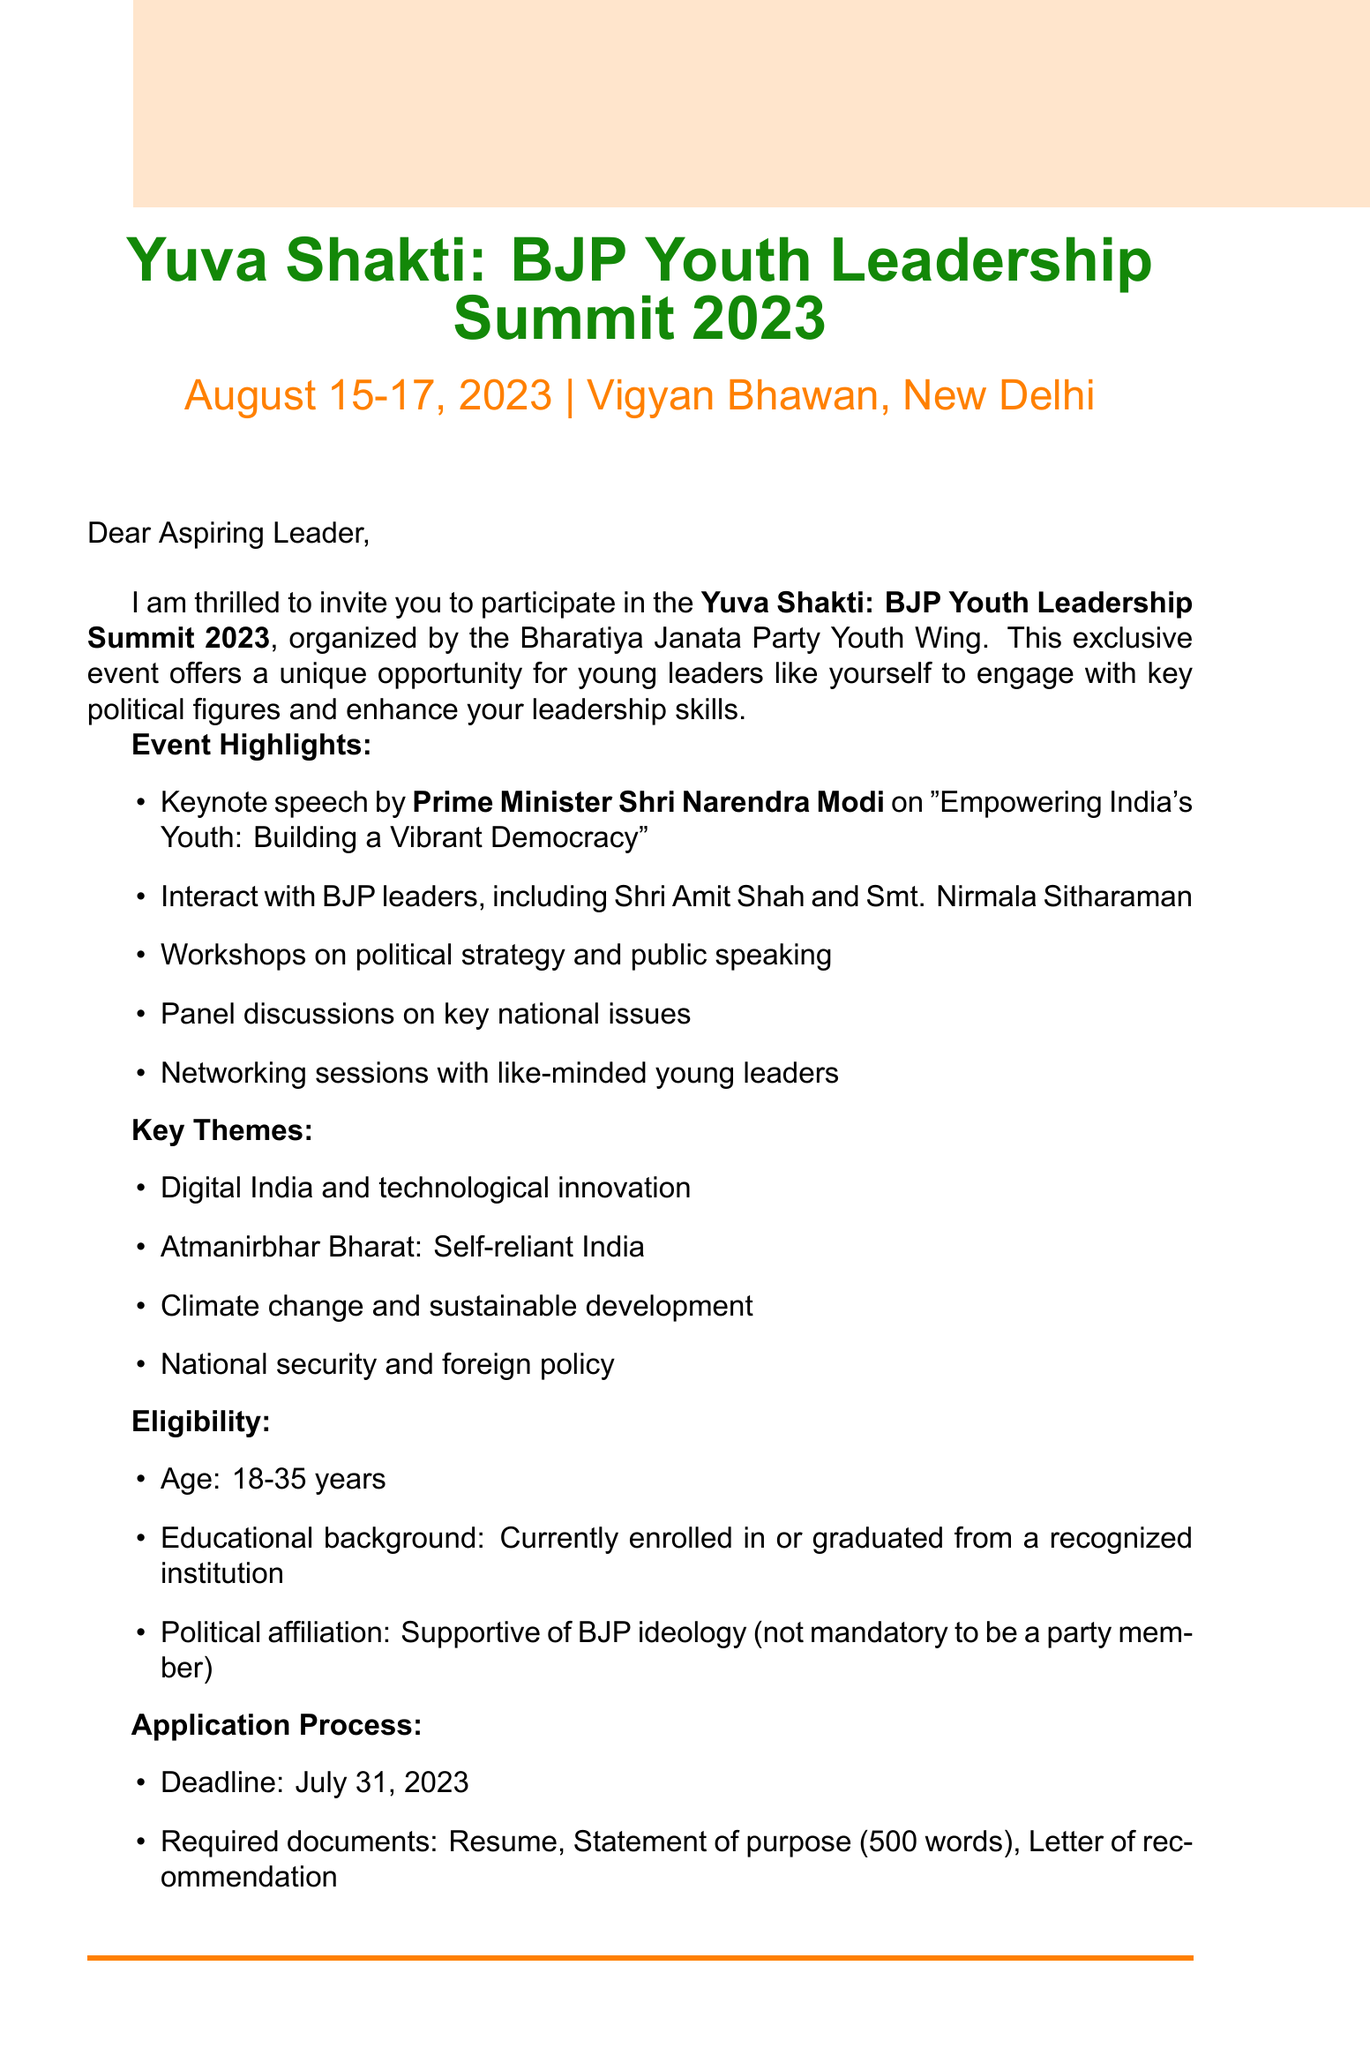What is the name of the event? The name of the event is stated in the title of the document.
Answer: Yuva Shakti: BJP Youth Leadership Summit 2023 Who is the keynote speaker? The document specifically mentions the keynote speaker and their title.
Answer: Shri Narendra Modi What is the date of the summit? The document provides the dates of the summit in the header.
Answer: August 15-17, 2023 What is the age range for eligibility? The eligibility criteria states the required age range for participants.
Answer: 18-35 years What type of document must be submitted for the application? The required documents section outlines the necessary materials for the application.
Answer: Letter of recommendation What is one of the key themes discussed at the summit? The document lists various key themes related to the summit.
Answer: Digital India and technological innovation What is the deadline for applications? The application process section specifies the deadline.
Answer: July 31, 2023 What type of lodging is provided for participants? The accommodation section details what is provided for participants.
Answer: Provided at ITC Maurya, New Delhi How many notable speakers are mentioned in the document? The number of notable speakers can be counted from the given list in the document.
Answer: Three 